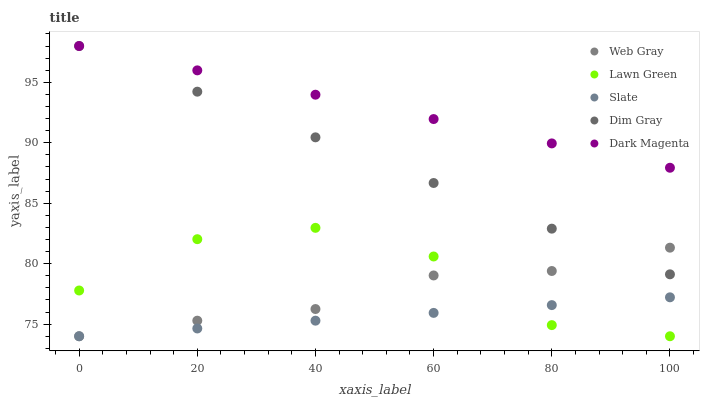Does Slate have the minimum area under the curve?
Answer yes or no. Yes. Does Dark Magenta have the maximum area under the curve?
Answer yes or no. Yes. Does Web Gray have the minimum area under the curve?
Answer yes or no. No. Does Web Gray have the maximum area under the curve?
Answer yes or no. No. Is Slate the smoothest?
Answer yes or no. Yes. Is Lawn Green the roughest?
Answer yes or no. Yes. Is Web Gray the smoothest?
Answer yes or no. No. Is Web Gray the roughest?
Answer yes or no. No. Does Lawn Green have the lowest value?
Answer yes or no. Yes. Does Dark Magenta have the lowest value?
Answer yes or no. No. Does Dim Gray have the highest value?
Answer yes or no. Yes. Does Web Gray have the highest value?
Answer yes or no. No. Is Lawn Green less than Dim Gray?
Answer yes or no. Yes. Is Dim Gray greater than Lawn Green?
Answer yes or no. Yes. Does Lawn Green intersect Web Gray?
Answer yes or no. Yes. Is Lawn Green less than Web Gray?
Answer yes or no. No. Is Lawn Green greater than Web Gray?
Answer yes or no. No. Does Lawn Green intersect Dim Gray?
Answer yes or no. No. 